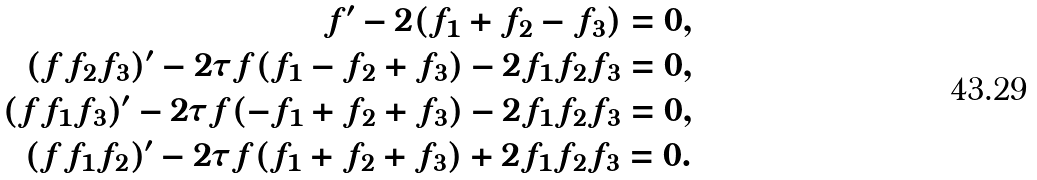Convert formula to latex. <formula><loc_0><loc_0><loc_500><loc_500>f ^ { \prime } - 2 ( f _ { 1 } + f _ { 2 } - f _ { 3 } ) = 0 , \\ ( f f _ { 2 } f _ { 3 } ) ^ { \prime } - 2 \tau f ( f _ { 1 } - f _ { 2 } + f _ { 3 } ) - 2 f _ { 1 } f _ { 2 } f _ { 3 } = 0 , \\ ( f f _ { 1 } f _ { 3 } ) ^ { \prime } - 2 \tau f ( - f _ { 1 } + f _ { 2 } + f _ { 3 } ) - 2 f _ { 1 } f _ { 2 } f _ { 3 } = 0 , \\ ( f f _ { 1 } f _ { 2 } ) ^ { \prime } - 2 \tau f ( f _ { 1 } + f _ { 2 } + f _ { 3 } ) + 2 f _ { 1 } f _ { 2 } f _ { 3 } = 0 .</formula> 